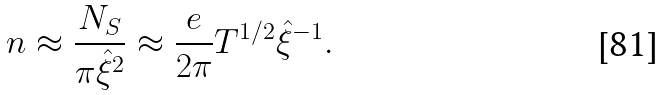Convert formula to latex. <formula><loc_0><loc_0><loc_500><loc_500>n \approx \frac { N _ { S } } { \pi \hat { \xi } ^ { 2 } } \approx \frac { e } { 2 \pi } T ^ { 1 / 2 } \hat { \xi } ^ { - 1 } .</formula> 